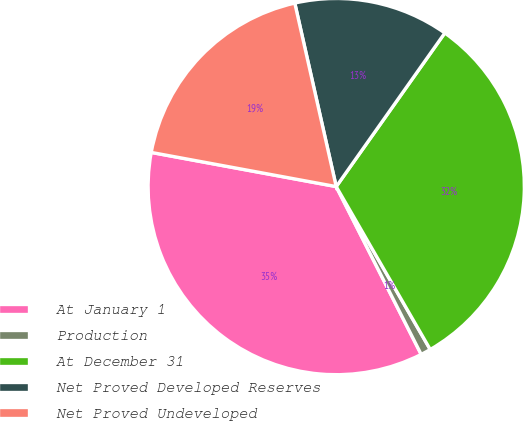<chart> <loc_0><loc_0><loc_500><loc_500><pie_chart><fcel>At January 1<fcel>Production<fcel>At December 31<fcel>Net Proved Developed Reserves<fcel>Net Proved Undeveloped<nl><fcel>35.37%<fcel>0.87%<fcel>31.88%<fcel>13.33%<fcel>18.56%<nl></chart> 